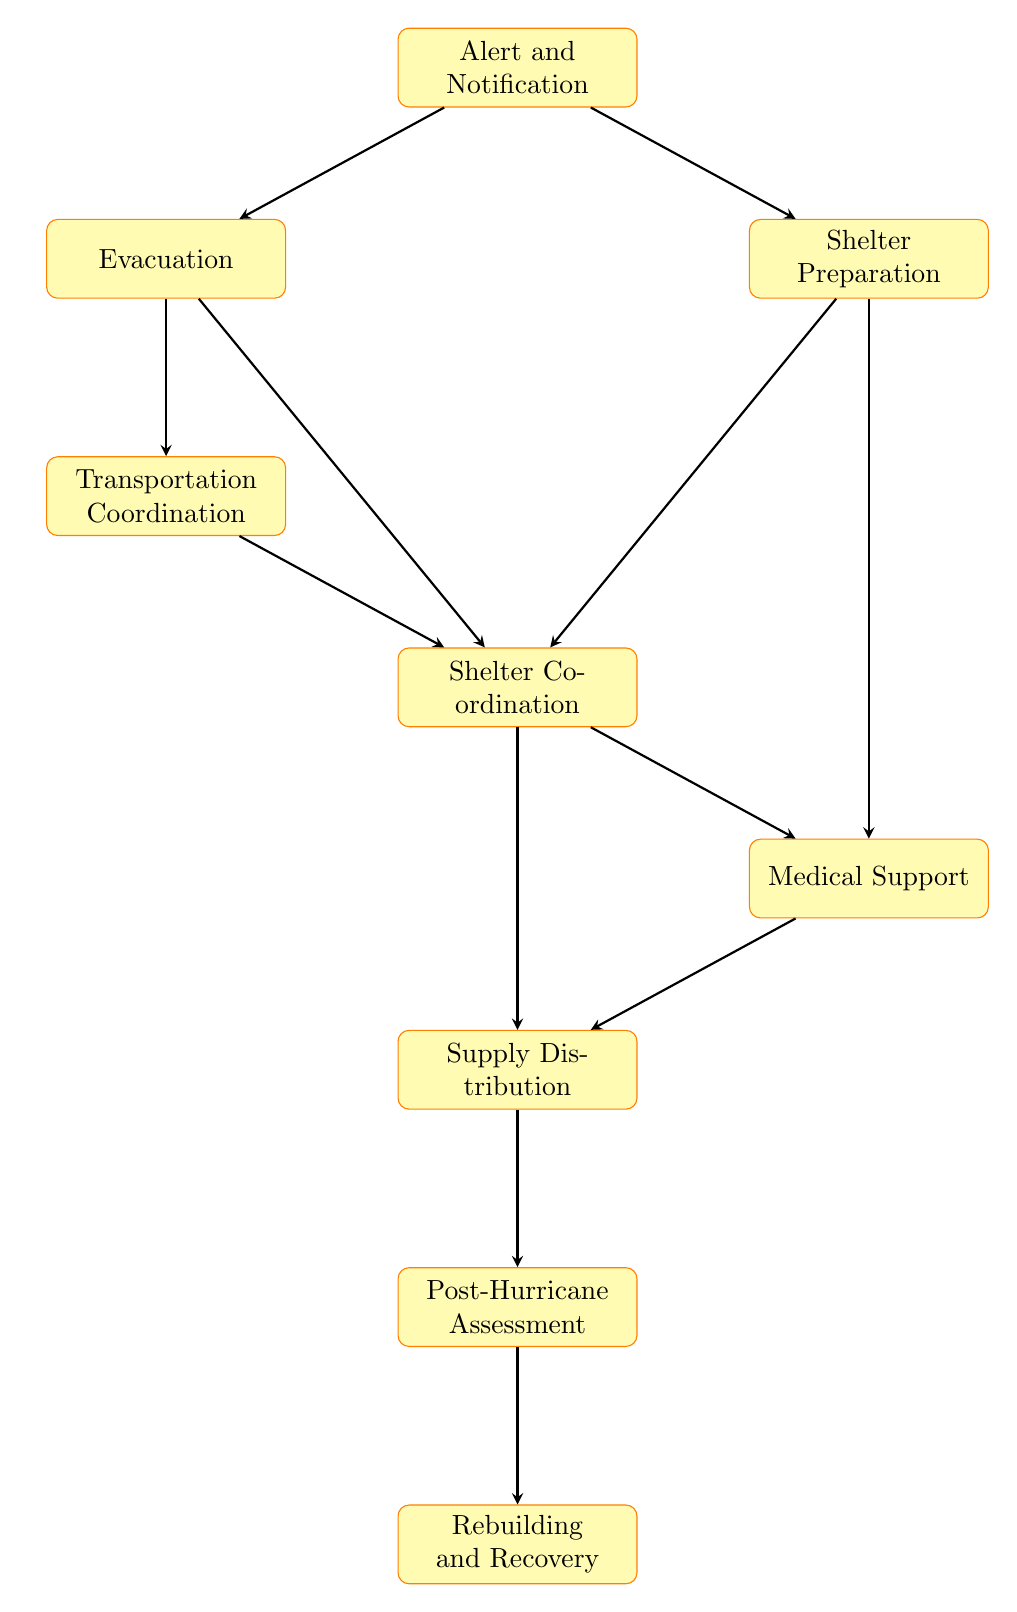What is the first step in the Emergency Response Plan? The diagram shows "Alert and Notification" as the starting point, indicating that the first action taken will be to notify community members about the incoming hurricane.
Answer: Alert and Notification How many nodes are in the flow chart? By counting the nodes illustrated in the diagram, we see there are a total of nine distinct processes that make up the Emergency Response Plan.
Answer: 9 What does the "Shelter Coordination" step lead to? "Shelter Coordination" is followed by two steps: "Medical Support" and "Supply Distribution," meaning that after coordinating shelters, support and supplies will be addressed.
Answer: Medical Support, Supply Distribution Which step comes after "Supply Distribution"? Following "Supply Distribution," the next process outlined in the diagram is "Post-Hurricane Assessment," indicating an evaluation phase after supplies are distributed.
Answer: Post-Hurricane Assessment What is the last step in the Emergency Response Plan? The flow chart culminates in "Rebuilding and Recovery," marking the endpoint of the response actions taken after the hurricane's impact has been assessed.
Answer: Rebuilding and Recovery What are the immediate steps after "Alert and Notification"? From "Alert and Notification," the immediate next actions are "Evacuation" and "Shelter Preparation," showing the branching paths following the initial alert.
Answer: Evacuation, Shelter Preparation Which node leads directly to "Transportation Coordination"? The "Evacuation" step directly leads to "Transportation Coordination," indicating that organizing transport for evacuees happens right after evacuating them.
Answer: Evacuation Which steps are involved in providing medical assistance? "Medical Support" is reached through "Shelter Coordination" and comes after "Shelter Preparation," illustrating that medical assistance is integrated into the shelter support process.
Answer: Shelter Coordination, Medical Support 